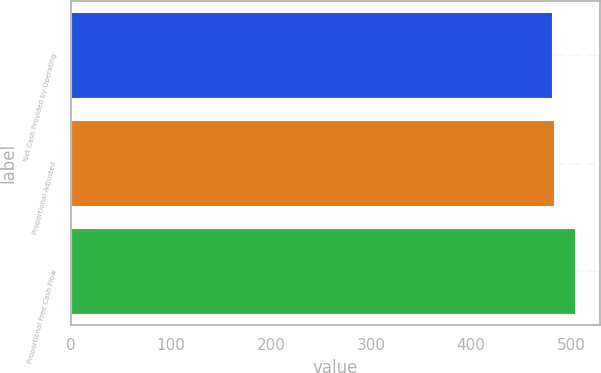<chart> <loc_0><loc_0><loc_500><loc_500><bar_chart><fcel>Net Cash Provided by Operating<fcel>Proportional Adjusted<fcel>Proportional Free Cash Flow<nl><fcel>481<fcel>483.3<fcel>504<nl></chart> 